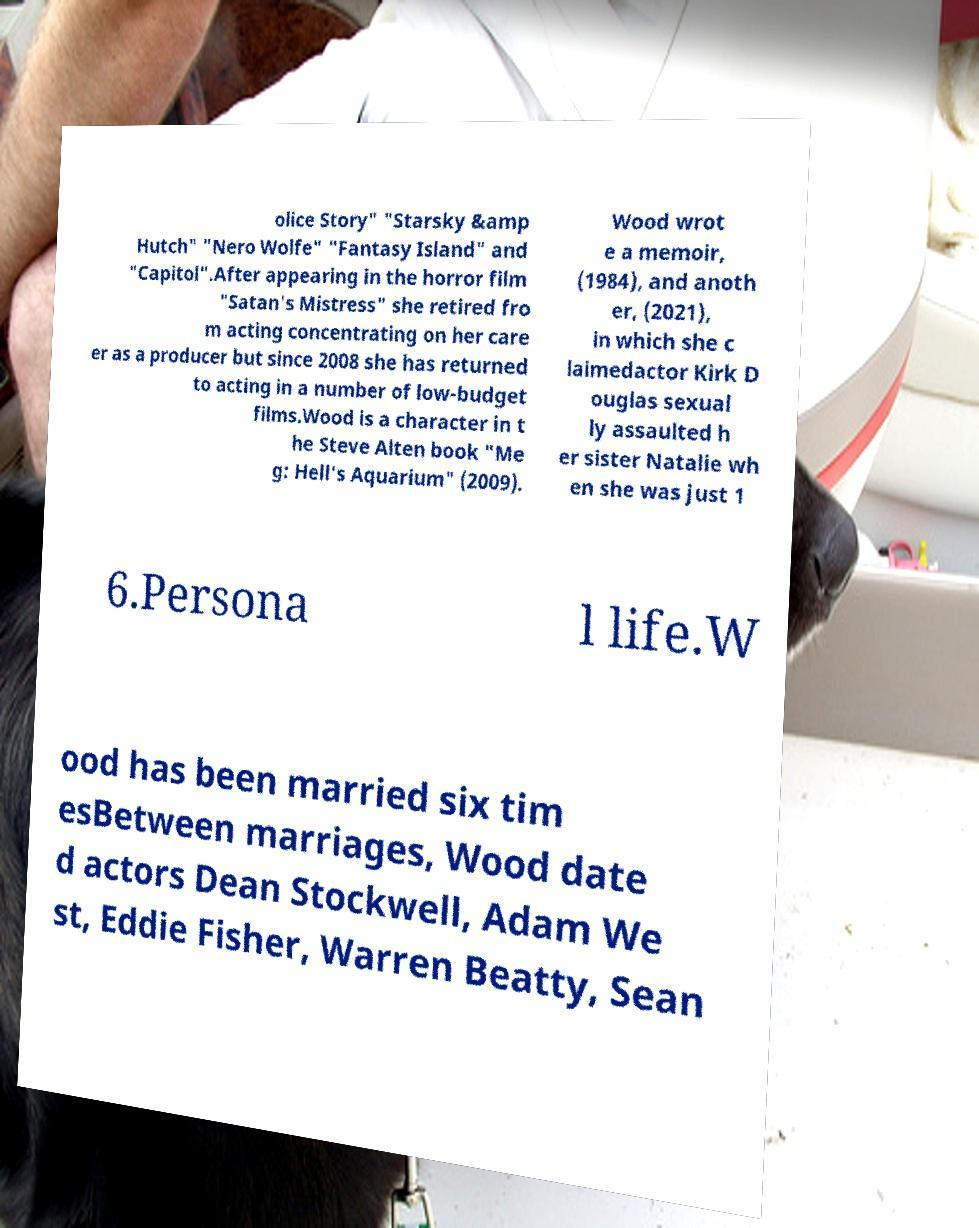Could you extract and type out the text from this image? olice Story" "Starsky &amp Hutch" "Nero Wolfe" "Fantasy Island" and "Capitol".After appearing in the horror film "Satan's Mistress" she retired fro m acting concentrating on her care er as a producer but since 2008 she has returned to acting in a number of low-budget films.Wood is a character in t he Steve Alten book "Me g: Hell's Aquarium" (2009). Wood wrot e a memoir, (1984), and anoth er, (2021), in which she c laimedactor Kirk D ouglas sexual ly assaulted h er sister Natalie wh en she was just 1 6.Persona l life.W ood has been married six tim esBetween marriages, Wood date d actors Dean Stockwell, Adam We st, Eddie Fisher, Warren Beatty, Sean 